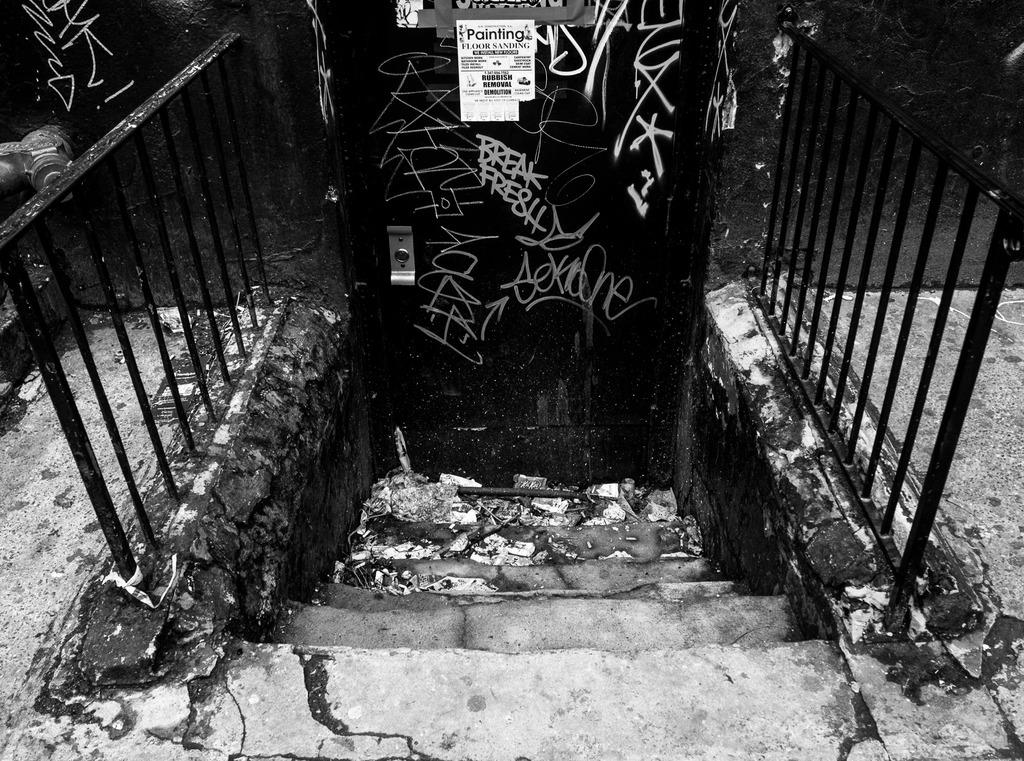What type of architectural feature is present in the image? There are stairs in the image. Is there any safety feature associated with the stairs? Yes, there is a railing in the image. What can be seen attached to a door in the background? Papers are attached to a door in the background. What is the color scheme of the image? The image is in black and white. How many cushions are present on the stairs in the image? There are no cushions present on the stairs in the image. Can you describe the feet of the person walking up the stairs in the image? There is no person present in the image, so we cannot describe their feet. 